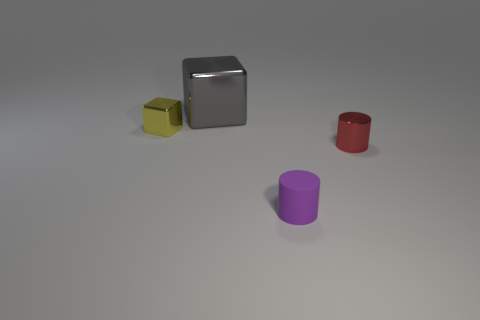Add 3 tiny red metallic objects. How many objects exist? 7 Add 3 tiny cubes. How many tiny cubes are left? 4 Add 4 tiny purple objects. How many tiny purple objects exist? 5 Subtract 1 gray blocks. How many objects are left? 3 Subtract all big things. Subtract all tiny red cylinders. How many objects are left? 2 